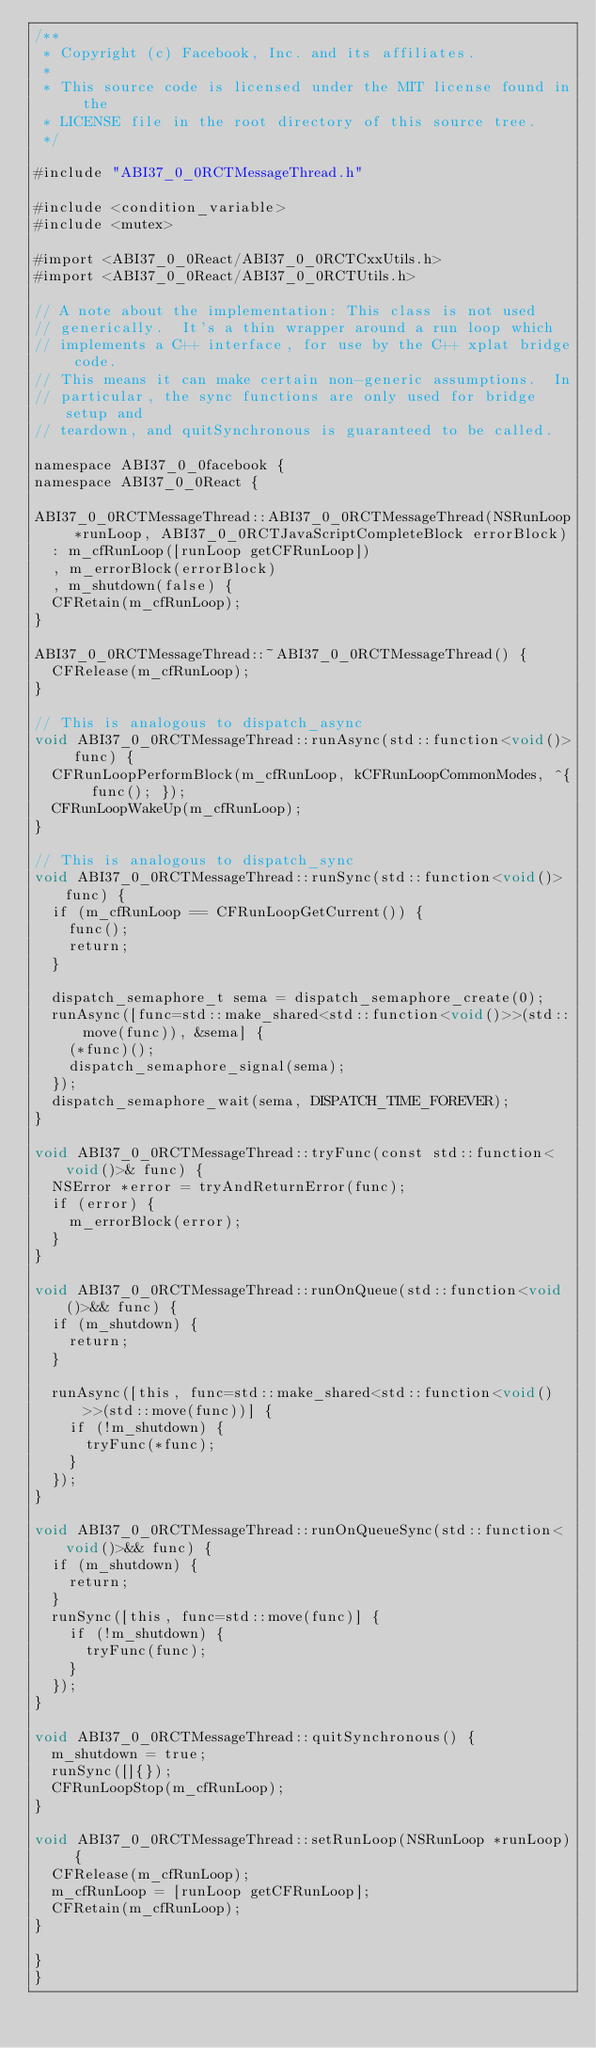Convert code to text. <code><loc_0><loc_0><loc_500><loc_500><_ObjectiveC_>/**
 * Copyright (c) Facebook, Inc. and its affiliates.
 *
 * This source code is licensed under the MIT license found in the
 * LICENSE file in the root directory of this source tree.
 */

#include "ABI37_0_0RCTMessageThread.h"

#include <condition_variable>
#include <mutex>

#import <ABI37_0_0React/ABI37_0_0RCTCxxUtils.h>
#import <ABI37_0_0React/ABI37_0_0RCTUtils.h>

// A note about the implementation: This class is not used
// generically.  It's a thin wrapper around a run loop which
// implements a C++ interface, for use by the C++ xplat bridge code.
// This means it can make certain non-generic assumptions.  In
// particular, the sync functions are only used for bridge setup and
// teardown, and quitSynchronous is guaranteed to be called.

namespace ABI37_0_0facebook {
namespace ABI37_0_0React {

ABI37_0_0RCTMessageThread::ABI37_0_0RCTMessageThread(NSRunLoop *runLoop, ABI37_0_0RCTJavaScriptCompleteBlock errorBlock)
  : m_cfRunLoop([runLoop getCFRunLoop])
  , m_errorBlock(errorBlock)
  , m_shutdown(false) {
  CFRetain(m_cfRunLoop);
}

ABI37_0_0RCTMessageThread::~ABI37_0_0RCTMessageThread() {
  CFRelease(m_cfRunLoop);
}

// This is analogous to dispatch_async
void ABI37_0_0RCTMessageThread::runAsync(std::function<void()> func) {
  CFRunLoopPerformBlock(m_cfRunLoop, kCFRunLoopCommonModes, ^{ func(); });
  CFRunLoopWakeUp(m_cfRunLoop);
}

// This is analogous to dispatch_sync
void ABI37_0_0RCTMessageThread::runSync(std::function<void()> func) {
  if (m_cfRunLoop == CFRunLoopGetCurrent()) {
    func();
    return;
  }

  dispatch_semaphore_t sema = dispatch_semaphore_create(0);
  runAsync([func=std::make_shared<std::function<void()>>(std::move(func)), &sema] {
    (*func)();
    dispatch_semaphore_signal(sema);
  });
  dispatch_semaphore_wait(sema, DISPATCH_TIME_FOREVER);
}

void ABI37_0_0RCTMessageThread::tryFunc(const std::function<void()>& func) {
  NSError *error = tryAndReturnError(func);
  if (error) {
    m_errorBlock(error);
  }
}

void ABI37_0_0RCTMessageThread::runOnQueue(std::function<void()>&& func) {
  if (m_shutdown) {
    return;
  }

  runAsync([this, func=std::make_shared<std::function<void()>>(std::move(func))] {
    if (!m_shutdown) {
      tryFunc(*func);
    }
  });
}

void ABI37_0_0RCTMessageThread::runOnQueueSync(std::function<void()>&& func) {
  if (m_shutdown) {
    return;
  }
  runSync([this, func=std::move(func)] {
    if (!m_shutdown) {
      tryFunc(func);
    }
  });
}

void ABI37_0_0RCTMessageThread::quitSynchronous() {
  m_shutdown = true;
  runSync([]{});
  CFRunLoopStop(m_cfRunLoop);
}

void ABI37_0_0RCTMessageThread::setRunLoop(NSRunLoop *runLoop) {
  CFRelease(m_cfRunLoop);
  m_cfRunLoop = [runLoop getCFRunLoop];
  CFRetain(m_cfRunLoop);
}

}
}
</code> 